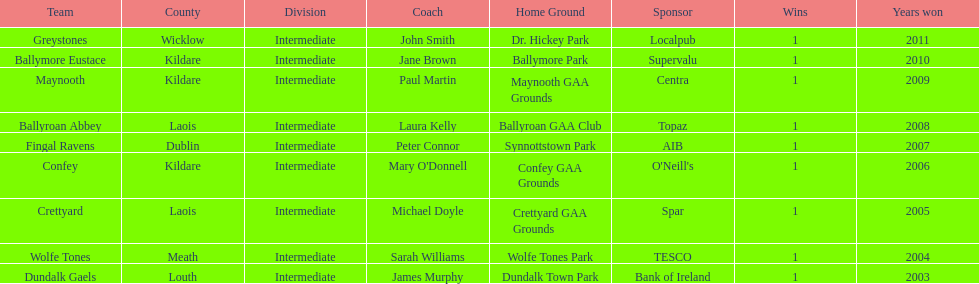Which team won previous to crettyard? Wolfe Tones. 